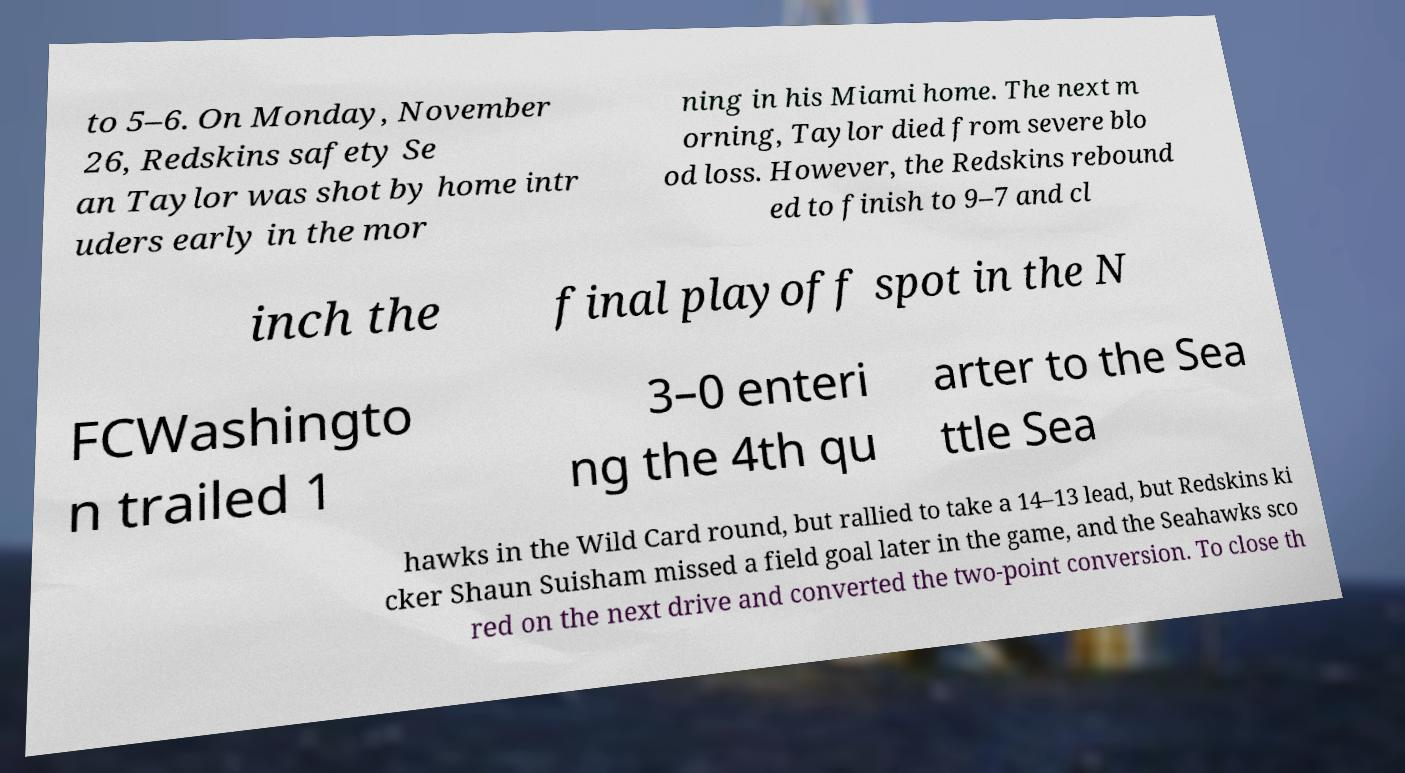For documentation purposes, I need the text within this image transcribed. Could you provide that? to 5–6. On Monday, November 26, Redskins safety Se an Taylor was shot by home intr uders early in the mor ning in his Miami home. The next m orning, Taylor died from severe blo od loss. However, the Redskins rebound ed to finish to 9–7 and cl inch the final playoff spot in the N FCWashingto n trailed 1 3–0 enteri ng the 4th qu arter to the Sea ttle Sea hawks in the Wild Card round, but rallied to take a 14–13 lead, but Redskins ki cker Shaun Suisham missed a field goal later in the game, and the Seahawks sco red on the next drive and converted the two-point conversion. To close th 